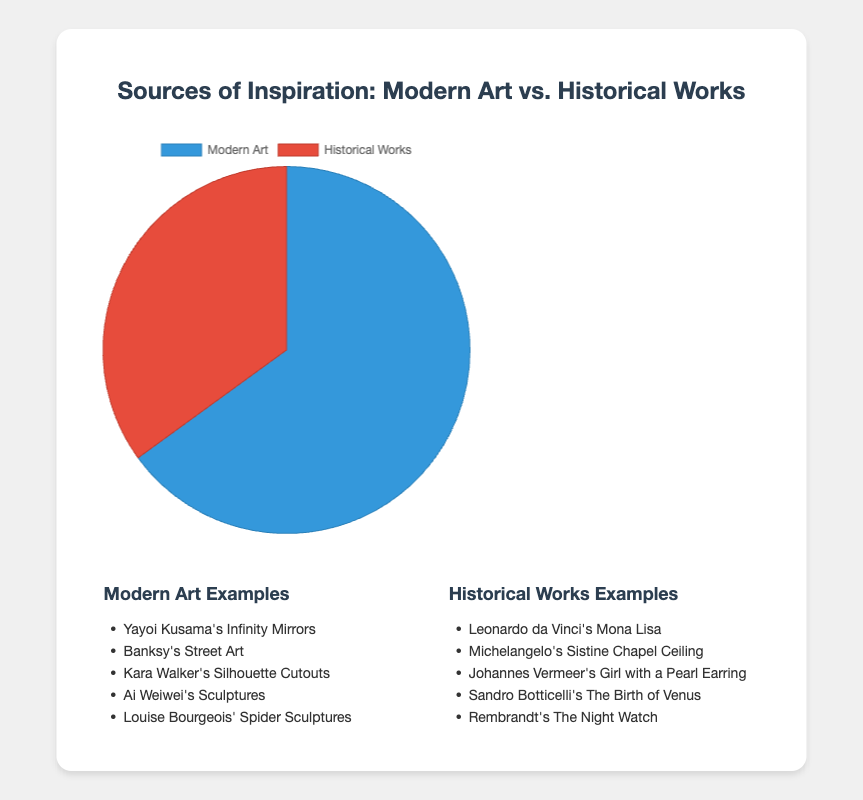what percentage of the sources of inspiration does modern art represent? The pie chart shows that modern art represents 65% of the sources of inspiration. The label "Modern Art" is attached to a section of the pie chart with a value of 65%.
Answer: 65% Which source of inspiration has a smaller percentage, modern art or historical works? The pie chart provides the percentages for Modern Art (65%) and Historical Works (35%). Since 35% is less than 65%, Historical Works has a smaller percentage.
Answer: Historical Works What are the combined percentages of both sources of inspiration? By adding the two given percentages: 65% (Modern Art) + 35% (Historical Works) = 100%, we get the combined percentage of both sources of inspiration.
Answer: 100% How much larger is modern art compared to historical works in terms of percentage? The difference between the percentages of Modern Art and Historical Works is calculated by subtracting the smaller percentage from the larger one: 65% - 35% = 30%.
Answer: 30% Is the percentage of modern art more than twice that of historical works? We need to check if 65% is more than twice 35%. Calculating twice 35% gives 70%. Since 65% is less than 70%, the percentage of Modern Art is not more than twice that of Historical Works.
Answer: No Which section of the pie chart is represented by the color blue? The pie chart's legend indicates that the section representing Modern Art is colored blue. Therefore, the blue section corresponds to Modern Art.
Answer: Modern Art How many examples of modern art are listed compared to historical works? The examples listed in the pie chart's accompanying text include 5 examples for Modern Art and 5 examples for Historical Works. By counting the examples, we see that the number of examples is equal.
Answer: Equal If an additional category "Contemporary Design" was added at 10%, how would the combined percentage of modern art and contemporary design compare to historical works? First, find the combined percentage of Modern Art and Contemporary Design: 65% + 10% = 75%. Next, compare 75% (Modern Art + Contemporary Design) to 35% (Historical Works). Since 75% is greater than 35%, the combined percentage is larger.
Answer: Larger What visual attribute differentiates the modern art and historical works sections in the pie chart? The pie chart uses distinct colors for visual differentiation: modern art is shown in blue, while historical works is shown in red.
Answer: Color What information is displayed above the pie chart in the title? The title of the pie chart, "Sources of Inspiration: Modern Art vs. Historical Works," provides an overview of the content and the comparison being shown.
Answer: Sources of Inspiration: Modern Art vs. Historical Works 